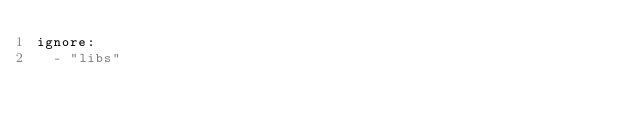Convert code to text. <code><loc_0><loc_0><loc_500><loc_500><_YAML_>ignore:
  - "libs"
</code> 